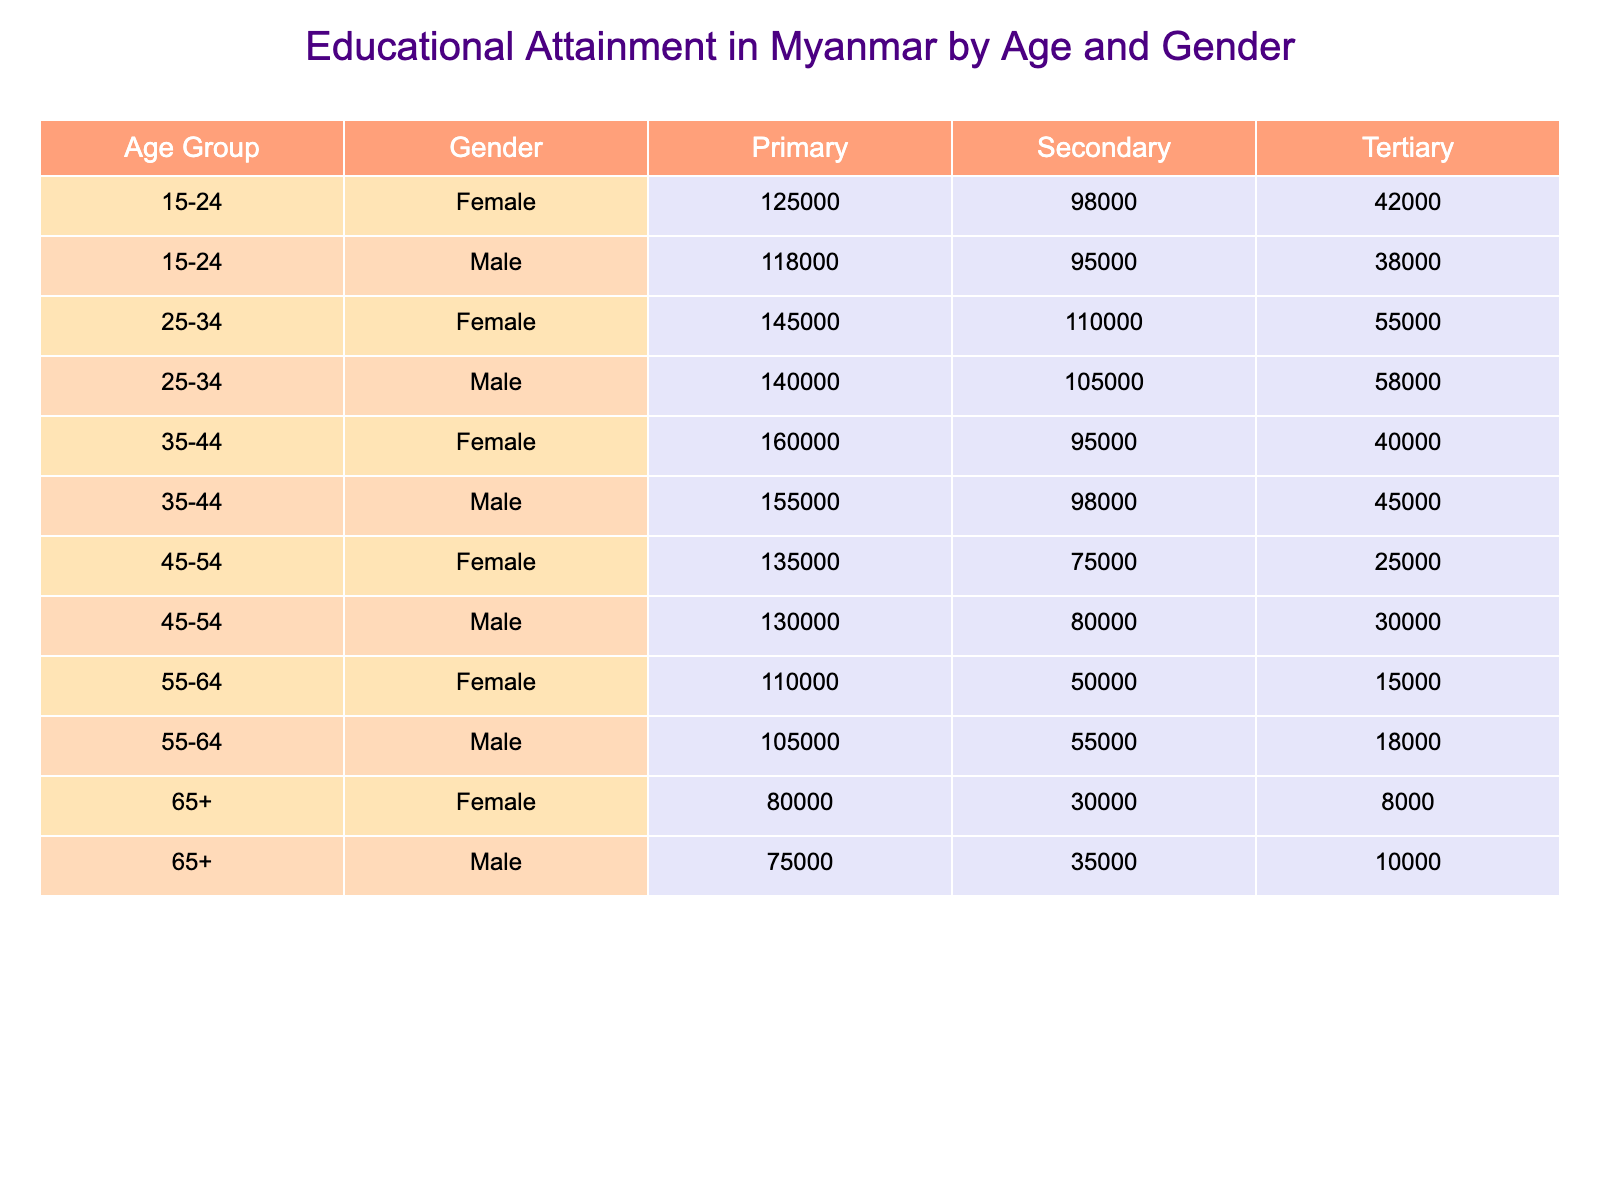What is the total number of females with secondary education in the age group 25-34? In the age group 25-34, the table shows that there are 110,000 females with secondary education. This value can be retrieved directly from the table under the corresponding age group and education level.
Answer: 110000 Which age group has the highest number of males with tertiary education? Looking at the table, in the age group 25-34, there are 58,000 males with tertiary education, which is higher than any other age group. Therefore, this age group has the highest number of males with tertiary education.
Answer: 25-34 What is the total number of people who have primary education across all age groups for males? To find the total for males with primary education, we add the values from all age groups: 118000 + 140000 + 155000 + 130000 + 105000 + 75000 = 818000. Thus, the total number of males with primary education is 818,000.
Answer: 818000 Are there more females or males in the age group 15-24 with tertiary education? In the age group 15-24, there are 42,000 females and 38,000 males with tertiary education. Comparing these values, females have 42,000, which is greater than the 38,000 males. Thus, in this age group, there are more females than males with tertiary education.
Answer: Yes What is the difference in the number of females with primary education between the age groups 35-44 and 45-54? For females, there are 160,000 in the 35-44 age group and 135,000 in the 45-54 age group with primary education. The difference is calculated as 160,000 - 135,000 = 25,000. This indicates that there are 25,000 more females with primary education in the 35-44 age group compared to the 45-54 age group.
Answer: 25000 What percentage of males aged 65+ have tertiary education? In the age group 65+, the total number of males is 75,000 (primary) + 35,000 (secondary) + 10,000 (tertiary) = 120,000. The number of males with tertiary education in this age group is 10,000. The percentage is then calculated as (10,000 / 120,000) * 100 = 8.33%. Therefore, approximately 8.33% of males aged 65+ have tertiary education.
Answer: 8.33% Which group has the least number of people with secondary education? Examining the table, we see that in the age group 65+, there are 30,000 females and 35,000 males with secondary education. All other age groups for females have greater values than these. Therefore, the group that has the least number of people with secondary education is the 65+ age group.
Answer: 65+ What is the average number of females with tertiary education across all age groups? To calculate the average, we first need the total number of females with tertiary education from all age groups: 42,000 + 55,000 + 40,000 + 25,000 + 15,000 + 8,000 = 185,000. There are 6 age groups, so the average is 185,000 / 6 = 30,833.33.
Answer: 30833.33 What is the total number of people with primary education in the 55-64 age group? In the 55-64 age group, the table indicates there are 110,000 females and 105,000 males with primary education. The total for this age group is 110,000 + 105,000 = 215,000.
Answer: 215000 